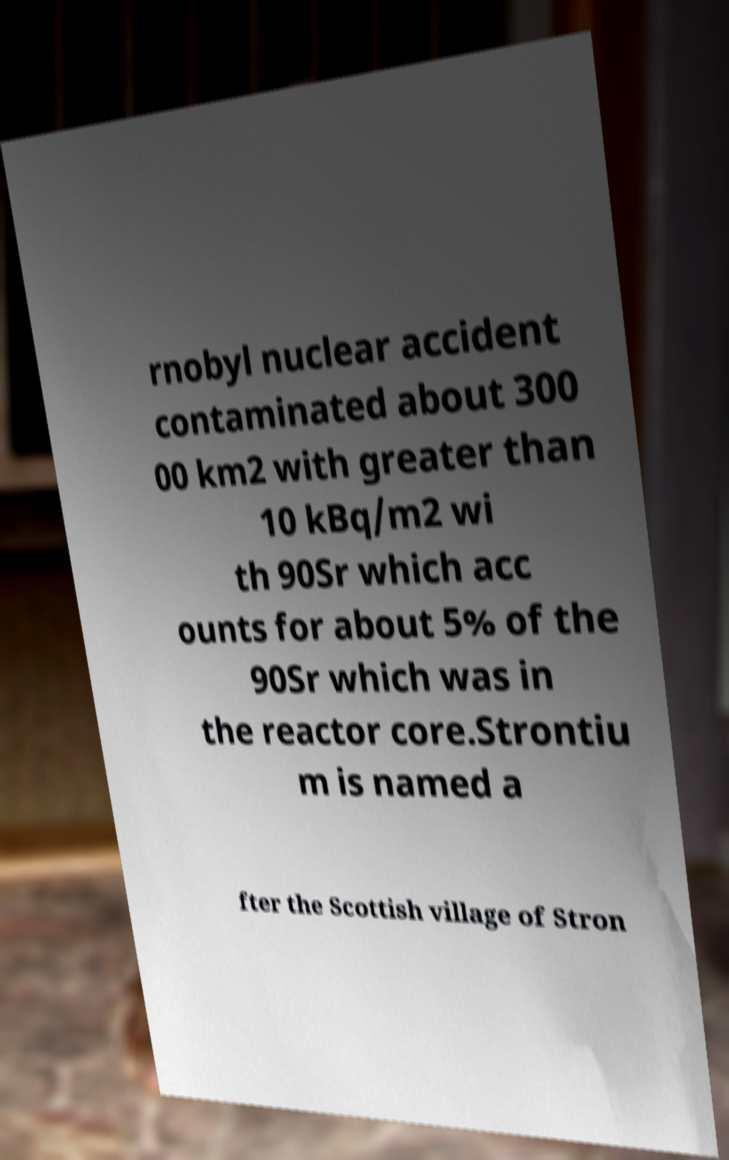Could you extract and type out the text from this image? rnobyl nuclear accident contaminated about 300 00 km2 with greater than 10 kBq/m2 wi th 90Sr which acc ounts for about 5% of the 90Sr which was in the reactor core.Strontiu m is named a fter the Scottish village of Stron 